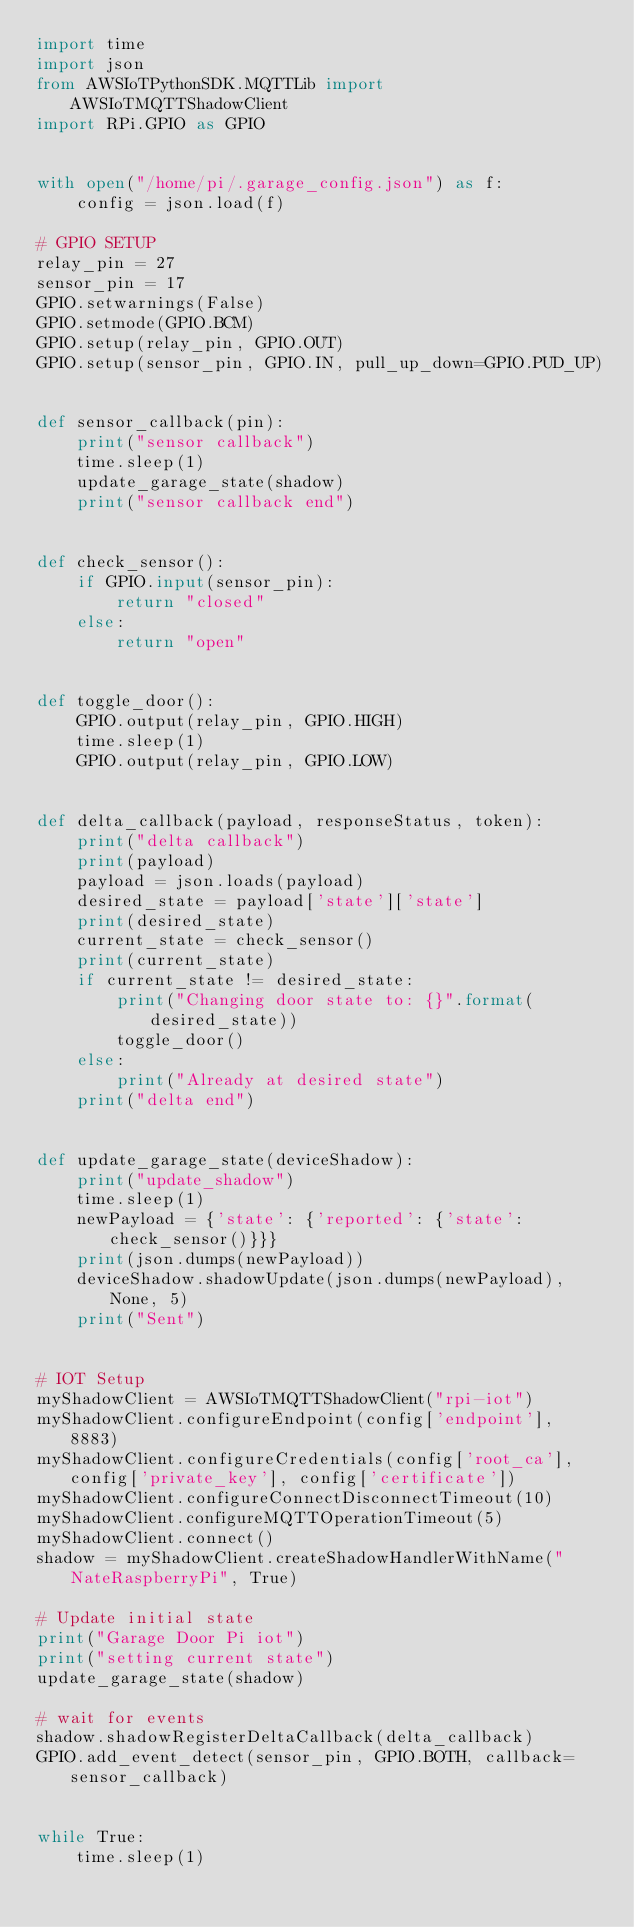Convert code to text. <code><loc_0><loc_0><loc_500><loc_500><_Python_>import time
import json
from AWSIoTPythonSDK.MQTTLib import AWSIoTMQTTShadowClient
import RPi.GPIO as GPIO


with open("/home/pi/.garage_config.json") as f:
    config = json.load(f)

# GPIO SETUP
relay_pin = 27
sensor_pin = 17
GPIO.setwarnings(False)
GPIO.setmode(GPIO.BCM)
GPIO.setup(relay_pin, GPIO.OUT)
GPIO.setup(sensor_pin, GPIO.IN, pull_up_down=GPIO.PUD_UP)


def sensor_callback(pin):
    print("sensor callback")
    time.sleep(1)
    update_garage_state(shadow)
    print("sensor callback end")


def check_sensor():
    if GPIO.input(sensor_pin):
        return "closed"
    else:
        return "open"


def toggle_door():
    GPIO.output(relay_pin, GPIO.HIGH)
    time.sleep(1)
    GPIO.output(relay_pin, GPIO.LOW)


def delta_callback(payload, responseStatus, token):
    print("delta callback")
    print(payload)
    payload = json.loads(payload)
    desired_state = payload['state']['state']
    print(desired_state)
    current_state = check_sensor()
    print(current_state)
    if current_state != desired_state:
        print("Changing door state to: {}".format(desired_state))
        toggle_door()
    else:
        print("Already at desired state")
    print("delta end")


def update_garage_state(deviceShadow):
    print("update_shadow")
    time.sleep(1)
    newPayload = {'state': {'reported': {'state': check_sensor()}}}
    print(json.dumps(newPayload))
    deviceShadow.shadowUpdate(json.dumps(newPayload), None, 5)
    print("Sent")


# IOT Setup
myShadowClient = AWSIoTMQTTShadowClient("rpi-iot")
myShadowClient.configureEndpoint(config['endpoint'], 8883)
myShadowClient.configureCredentials(config['root_ca'], config['private_key'], config['certificate'])
myShadowClient.configureConnectDisconnectTimeout(10)
myShadowClient.configureMQTTOperationTimeout(5)
myShadowClient.connect()
shadow = myShadowClient.createShadowHandlerWithName("NateRaspberryPi", True)

# Update initial state
print("Garage Door Pi iot")
print("setting current state")
update_garage_state(shadow)

# wait for events
shadow.shadowRegisterDeltaCallback(delta_callback)
GPIO.add_event_detect(sensor_pin, GPIO.BOTH, callback=sensor_callback)


while True:
    time.sleep(1)
</code> 